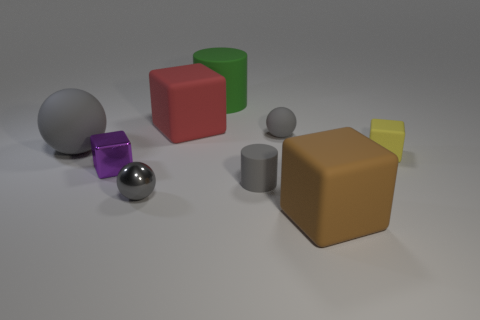How many large cylinders have the same material as the large brown block? Upon reviewing the image, the large brown block appears to be matte in nature. There is one large cylinder, which seems to be made of a similar matte material. Therefore, there is one large cylinder that shares the same material as the large brown block. 